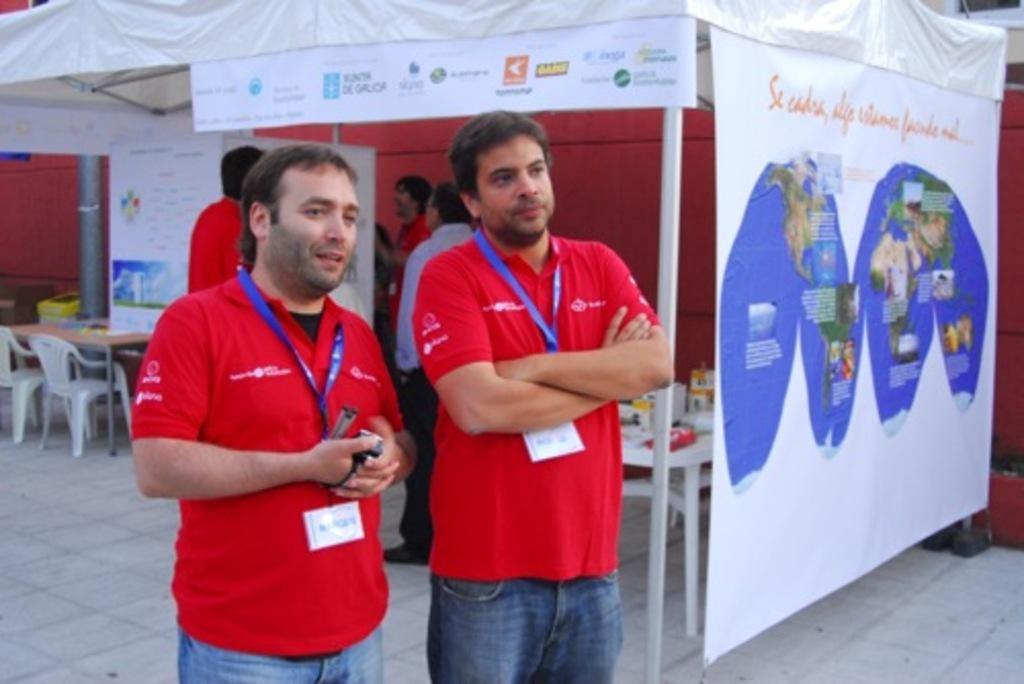How many people are in the image? There are persons standing in the image. What surface are the persons standing on? The persons are standing on the floor. What type of furniture is present in the image? There are chairs and tables in the image. What type of containers are present in the image? Cardboard cartons are present in the image. What type of visuals are visible in the image? Advertisements are visible in the image. What other object can be seen in the image? There is a pole in the image. What type of shoe is being compared in the image? There is no shoe present in the image, nor is there any comparison being made. 